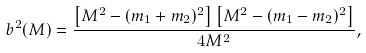<formula> <loc_0><loc_0><loc_500><loc_500>b ^ { 2 } ( M ) = \frac { \left [ M ^ { 2 } - ( m _ { 1 } + m _ { 2 } ) ^ { 2 } \right ] \left [ M ^ { 2 } - ( m _ { 1 } - m _ { 2 } ) ^ { 2 } \right ] } { 4 M ^ { 2 } } ,</formula> 